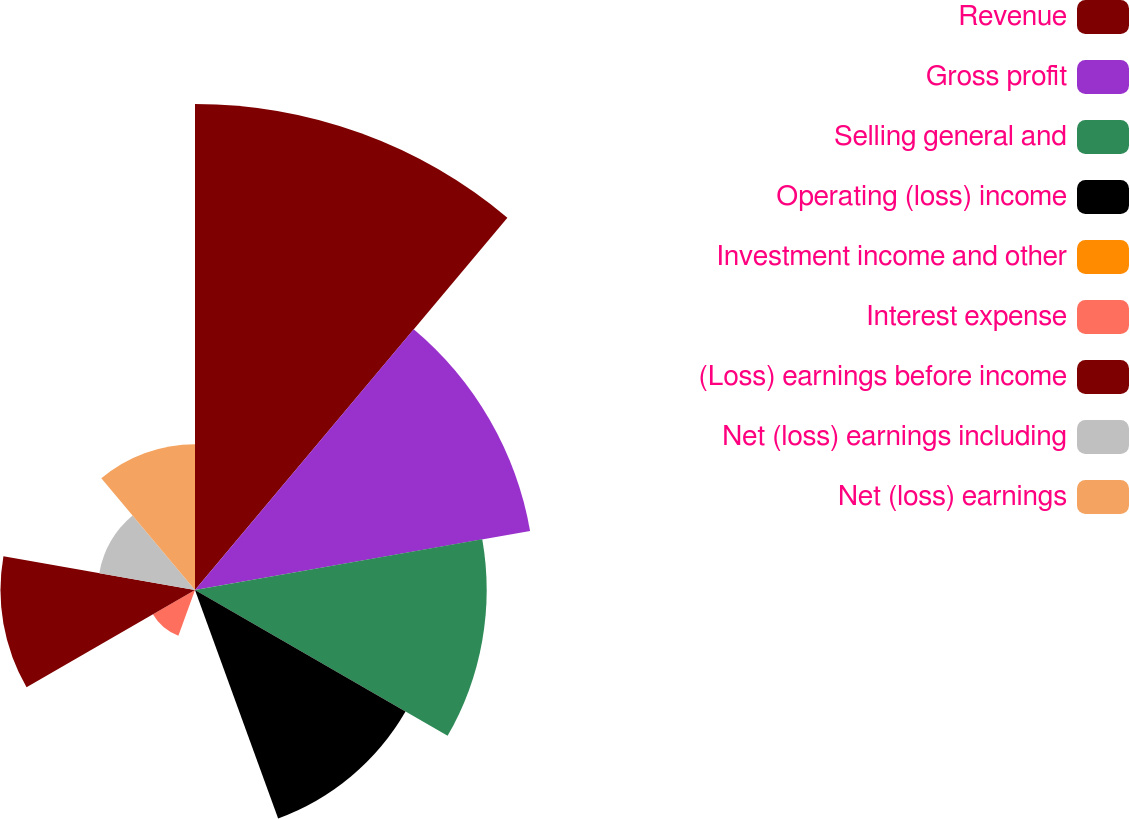<chart> <loc_0><loc_0><loc_500><loc_500><pie_chart><fcel>Revenue<fcel>Gross profit<fcel>Selling general and<fcel>Operating (loss) income<fcel>Investment income and other<fcel>Interest expense<fcel>(Loss) earnings before income<fcel>Net (loss) earnings including<fcel>Net (loss) earnings<nl><fcel>26.31%<fcel>18.42%<fcel>15.79%<fcel>13.16%<fcel>0.0%<fcel>2.63%<fcel>10.53%<fcel>5.26%<fcel>7.89%<nl></chart> 